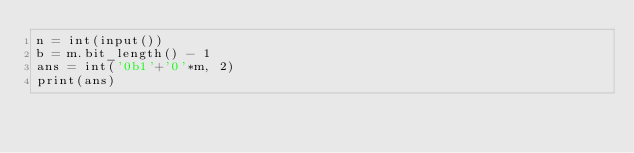<code> <loc_0><loc_0><loc_500><loc_500><_Python_>n = int(input())
b = m.bit_length() - 1
ans = int('0b1'+'0'*m, 2)
print(ans)</code> 